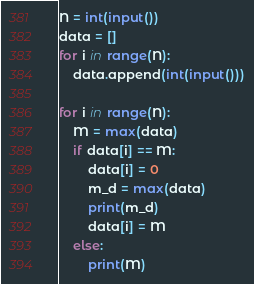Convert code to text. <code><loc_0><loc_0><loc_500><loc_500><_Python_>N = int(input())
data = []
for i in range(N):
    data.append(int(input()))

for i in range(N):
    M = max(data)
    if data[i] == M:
        data[i] = 0
        m_d = max(data)
        print(m_d)
        data[i] = M
    else:
        print(M)
</code> 